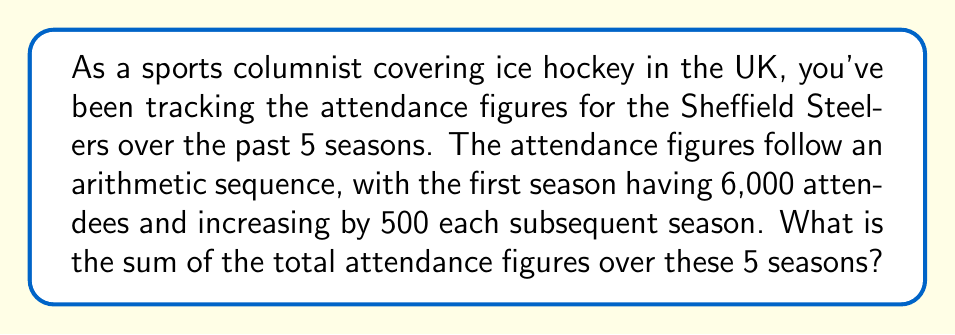Teach me how to tackle this problem. Let's approach this step-by-step using the arithmetic sequence formula:

1) First, we identify the components of our arithmetic sequence:
   $a_1 = 6000$ (first term)
   $d = 500$ (common difference)
   $n = 5$ (number of terms)

2) The arithmetic sequence formula for the nth term is:
   $a_n = a_1 + (n-1)d$

3) We can calculate the last term ($a_5$) using this formula:
   $a_5 = 6000 + (5-1)500 = 6000 + 2000 = 8000$

4) Now that we have the first term ($a_1$) and the last term ($a_5$), we can use the formula for the sum of an arithmetic sequence:
   $S_n = \frac{n}{2}(a_1 + a_n)$

   Where:
   $S_n$ is the sum of the sequence
   $n$ is the number of terms
   $a_1$ is the first term
   $a_n$ is the last term

5) Substituting our values:
   $S_5 = \frac{5}{2}(6000 + 8000)$

6) Simplifying:
   $S_5 = \frac{5}{2}(14000) = 5 \times 7000 = 35000$

Therefore, the sum of the total attendance figures over these 5 seasons is 35,000.
Answer: 35,000 attendees 